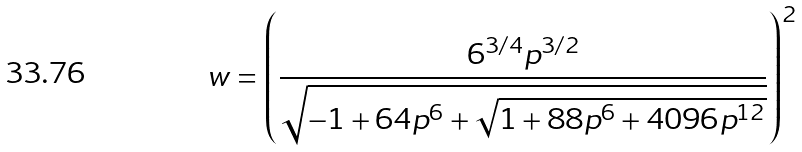<formula> <loc_0><loc_0><loc_500><loc_500>w = \left ( \frac { 6 ^ { 3 / 4 } p ^ { 3 / 2 } } { \sqrt { - 1 + 6 4 p ^ { 6 } + \sqrt { 1 + 8 8 p ^ { 6 } + 4 0 9 6 p ^ { 1 2 } } } } \right ) ^ { 2 }</formula> 